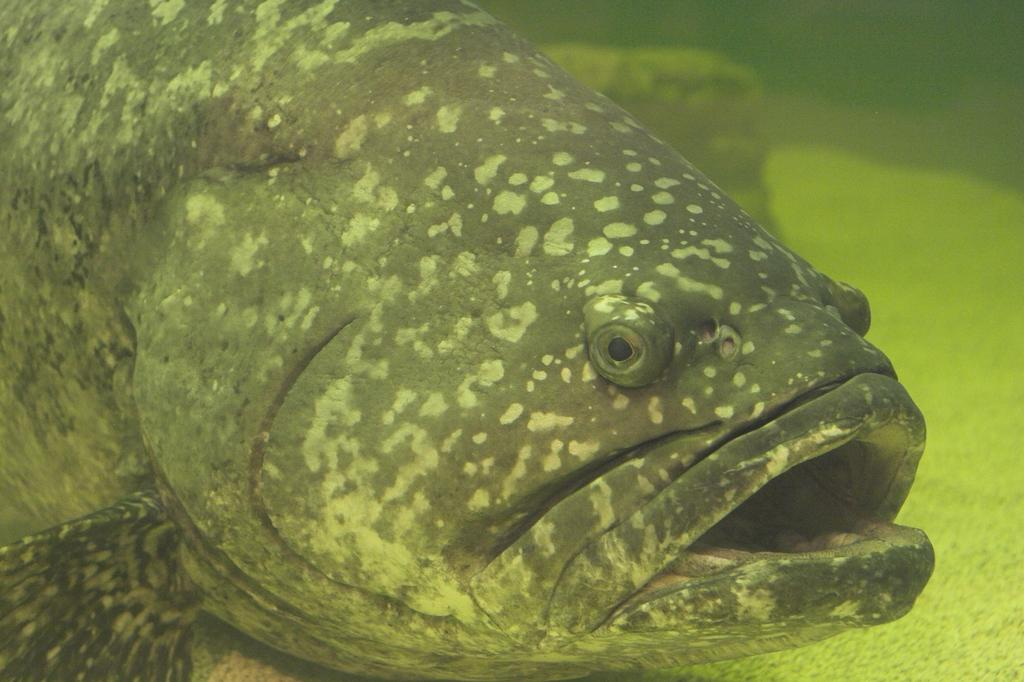What type of animal can be seen in the water in the image? There is a fish in the water in the image. What else can be seen in the water in the image? There are objects visible in the background under the water. What type of container is holding the fish in the image? There is no container holding the fish in the image; it is swimming freely in the water. What type of can is visible in the image? There is no can present in the image. 